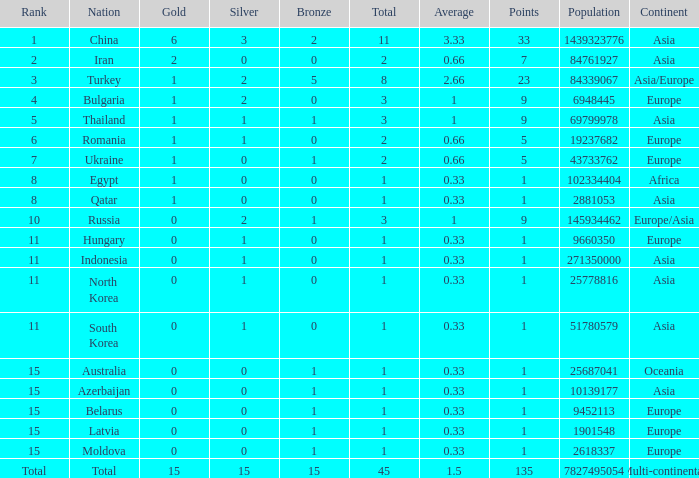What is the highest amount of bronze china, which has more than 1 gold and more than 11 total, has? None. Write the full table. {'header': ['Rank', 'Nation', 'Gold', 'Silver', 'Bronze', 'Total', 'Average', 'Points', 'Population', 'Continent'], 'rows': [['1', 'China', '6', '3', '2', '11', '3.33', '33', '1439323776', 'Asia'], ['2', 'Iran', '2', '0', '0', '2', '0.66', '7', '84761927', 'Asia'], ['3', 'Turkey', '1', '2', '5', '8', '2.66', '23', '84339067', 'Asia/Europe'], ['4', 'Bulgaria', '1', '2', '0', '3', '1', '9', '6948445', 'Europe'], ['5', 'Thailand', '1', '1', '1', '3', '1', '9', '69799978', 'Asia'], ['6', 'Romania', '1', '1', '0', '2', '0.66', '5', '19237682', 'Europe'], ['7', 'Ukraine', '1', '0', '1', '2', '0.66', '5', '43733762', 'Europe'], ['8', 'Egypt', '1', '0', '0', '1', '0.33', '1', '102334404', 'Africa'], ['8', 'Qatar', '1', '0', '0', '1', '0.33', '1', '2881053', 'Asia'], ['10', 'Russia', '0', '2', '1', '3', '1', '9', '145934462', 'Europe/Asia'], ['11', 'Hungary', '0', '1', '0', '1', '0.33', '1', '9660350', 'Europe'], ['11', 'Indonesia', '0', '1', '0', '1', '0.33', '1', '271350000', 'Asia'], ['11', 'North Korea', '0', '1', '0', '1', '0.33', '1', '25778816', 'Asia'], ['11', 'South Korea', '0', '1', '0', '1', '0.33', '1', '51780579', 'Asia'], ['15', 'Australia', '0', '0', '1', '1', '0.33', '1', '25687041', 'Oceania'], ['15', 'Azerbaijan', '0', '0', '1', '1', '0.33', '1', '10139177', 'Asia'], ['15', 'Belarus', '0', '0', '1', '1', '0.33', '1', '9452113', 'Europe'], ['15', 'Latvia', '0', '0', '1', '1', '0.33', '1', '1901548', 'Europe'], ['15', 'Moldova', '0', '0', '1', '1', '0.33', '1', '2618337', 'Europe'], ['Total', 'Total', '15', '15', '15', '45', '1.5', '135', '7827495054', 'Multi-continental']]} 